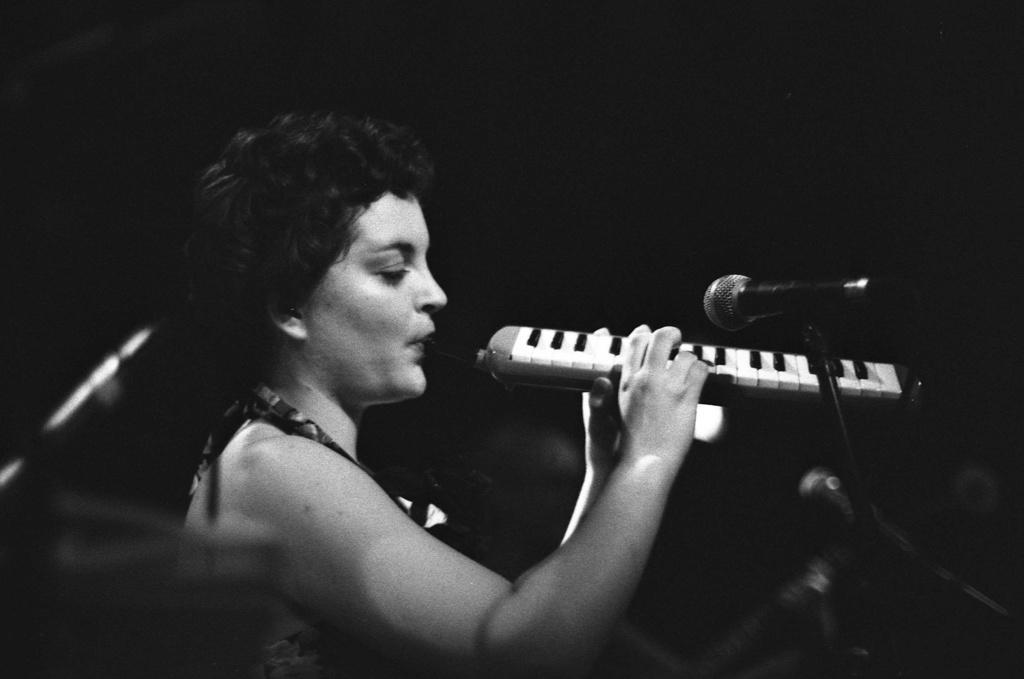Please provide a concise description of this image. In this picture we can see a woman playing a musical instrument. There is a mic. 